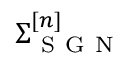Convert formula to latex. <formula><loc_0><loc_0><loc_500><loc_500>\Sigma _ { S G N } ^ { [ n ] }</formula> 